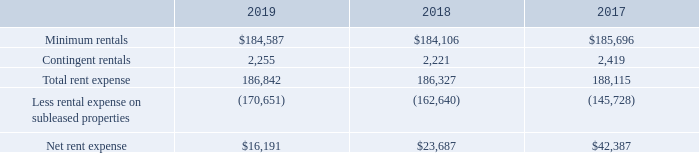As lessee — We lease restaurants and other facilities, which generally have renewal clauses of 1 to 20 years exercisable at our option. In some instances, these leases have provisions for contingent rentals based upon a percentage of defined revenues. Many of our restaurant and other facility leases also have rent escalation clauses and require the payment of property taxes, insurance, and maintenance costs. We also lease certain restaurant and office equipment. Minimum rental obligations are accounted for on a straight-line basis over the term of the initial lease, plus lease option terms for certain locations.
The components of rent expense were as follows in each fiscal year (in thousands):
What are the durations of renewal clauses in general? 1 to 20 years. What is the net rent expense in 2019?
Answer scale should be: thousand. $16,191. What is the value of minimum rentals in 2019?
Answer scale should be: thousand. $184,587. What is the difference in net rent expense between 2017 and 2018?
Answer scale should be: thousand. $42,387 - $23,687
Answer: 18700. What is the average contingent rentals for years 2017, 2018 and 2019?
Answer scale should be: thousand. (2,255+2,221+2,419)/3
Answer: 2298.33. What is the difference in minimum rentals between 2018 and 2019?
Answer scale should be: thousand. 184,587-184,106
Answer: 481. 